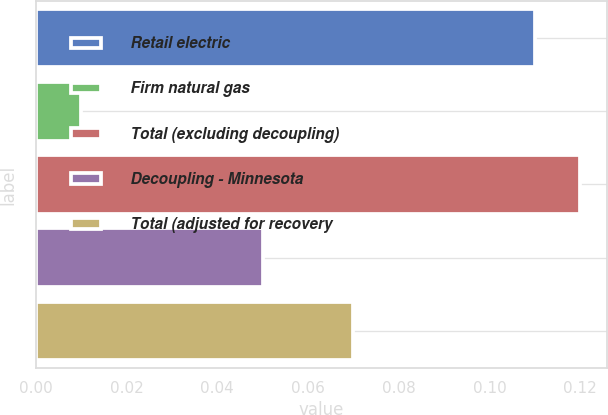Convert chart. <chart><loc_0><loc_0><loc_500><loc_500><bar_chart><fcel>Retail electric<fcel>Firm natural gas<fcel>Total (excluding decoupling)<fcel>Decoupling - Minnesota<fcel>Total (adjusted for recovery<nl><fcel>0.11<fcel>0.01<fcel>0.12<fcel>0.05<fcel>0.07<nl></chart> 